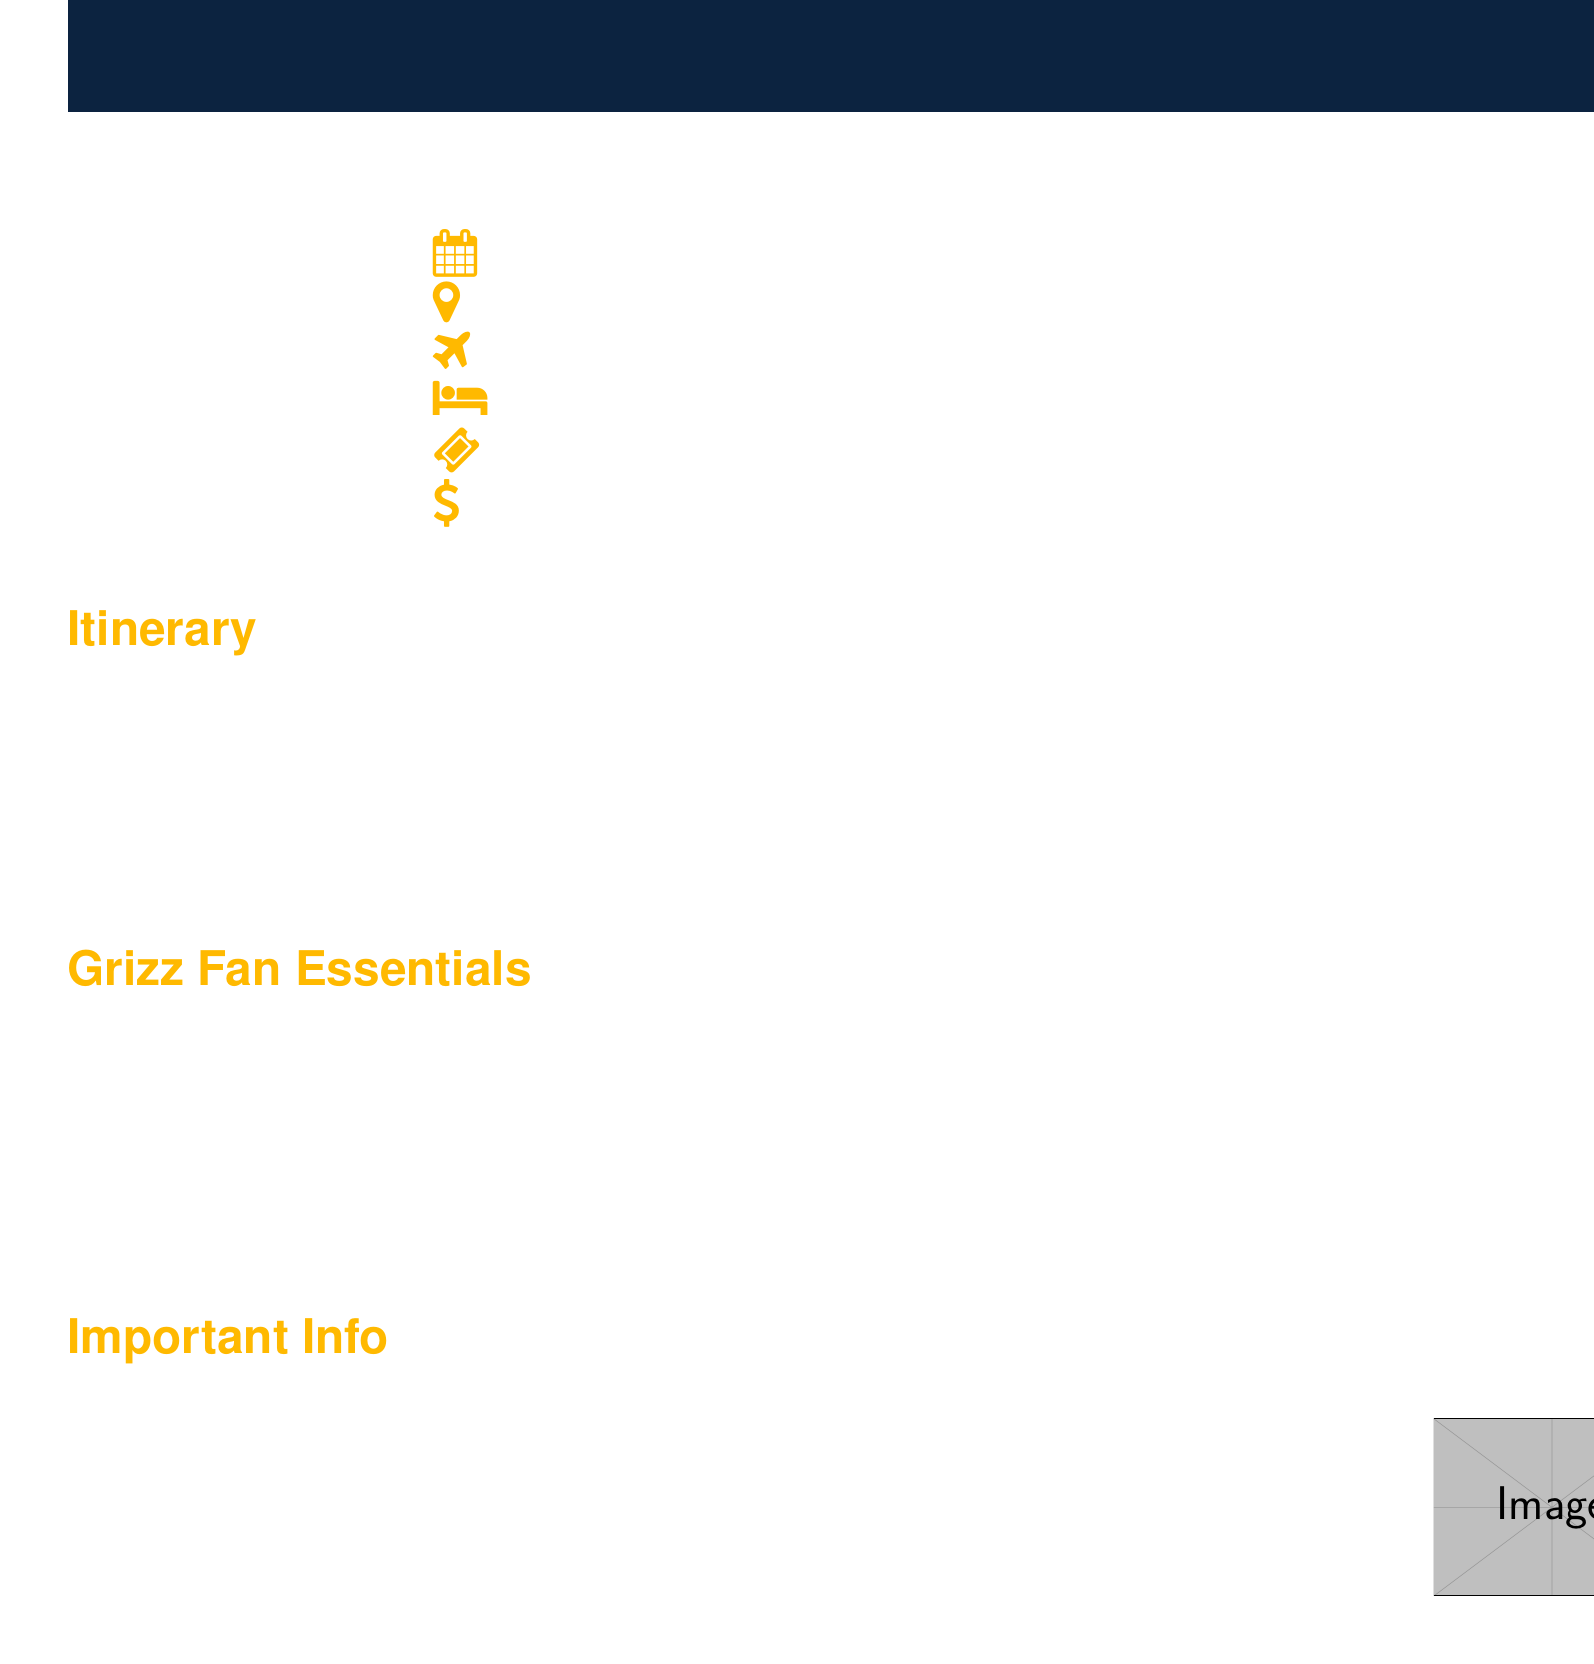What is the purpose of the trip? The purpose of the trip is stated at the beginning, which is to attend a Memphis Grizzlies away game.
Answer: Memphis Grizzlies away game against the Golden State Warriors What is the date of the game? The document provides the specific date when the game will occur, which is March 15, 2024.
Answer: March 15, 2024 What is the estimated total cost per person? The document mentions the estimated total cost for the trip, which is specified as $850 per person.
Answer: $850 per person When is the payment deadline? The document indicates the deadline for payment, which is set for February 1, 2024.
Answer: February 1, 2024 Who is the emergency contact for the trip? The document lists an emergency contact for the group during the trip, identifying them by name and phone number.
Answer: John Davis (Group Leader): 901-555-1234 What activities are planned for March 15, 2024? The document outlines specific activities scheduled for that date, including visiting landmarks and attending the game.
Answer: Breakfast at hotel, Visit Golden Gate Bridge, Lunch at Fisherman's Wharf, Pre-game meetup at Grill House at Chase Center, Watch Grizzlies vs. Warriors game, Post-game celebration (if Grizzlies win) at Harmonic Brewing What hotel will the group stay at? The document provides information about accommodations, specifying the name of the hotel.
Answer: Hilton San Francisco Union Square What platform will be used for group communication? The communication method for the group is mentioned in the document, highlighting the platform chosen for real-time updates.
Answer: WhatsApp group 